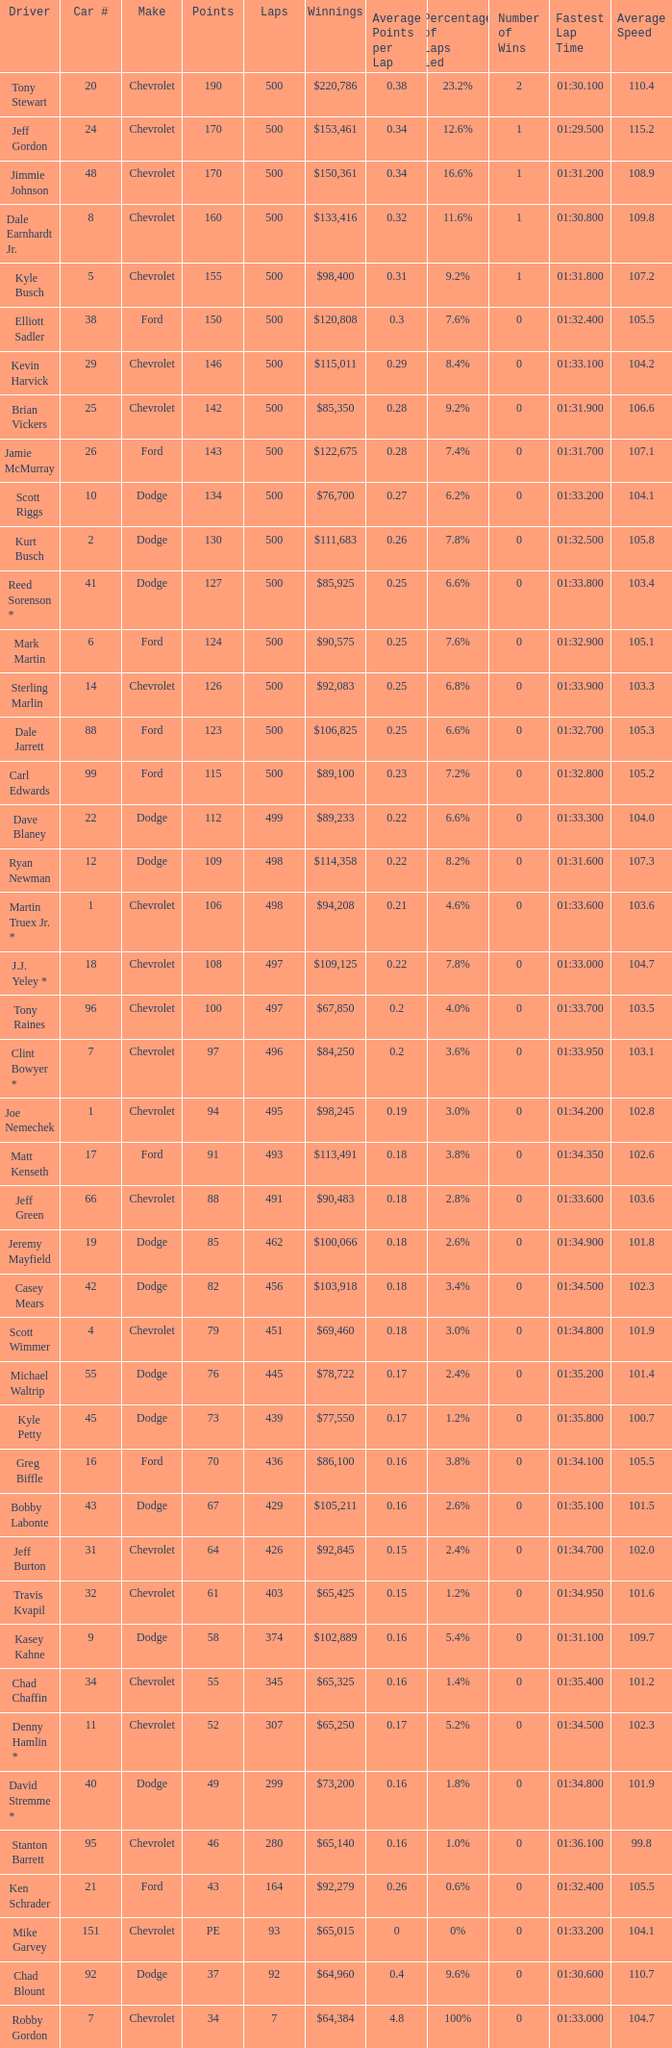What is the average car number of all the drivers who have won $111,683? 2.0. 